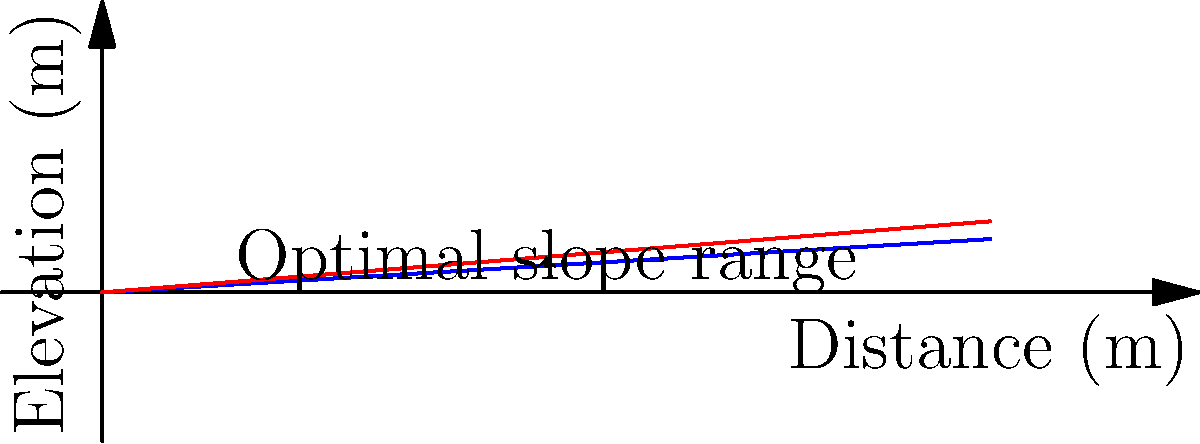As a civil engineer designing a road in Rocklin, you need to determine the optimal slope for proper drainage and safety. Given that the minimum slope for adequate drainage is 6% and the maximum safe slope for vehicles is 8%, what range of slopes (in percent) would you recommend for the road design? Consider factors such as local weather conditions and the hilly terrain of Rocklin. To determine the optimal slope range, we need to consider both the minimum slope for adequate drainage and the maximum safe slope for vehicles. Let's break this down step-by-step:

1. Minimum slope for adequate drainage: 6%
   - This ensures water will flow off the road surface, preventing pooling and potential hydroplaning.

2. Maximum safe slope for vehicles: 8%
   - This limit is set to ensure vehicles can safely navigate the road, especially during wet conditions or when there's reduced traction.

3. Considering Rocklin's local conditions:
   - Rocklin has a Mediterranean climate with hot, dry summers and cool, wet winters.
   - The terrain is hilly, which necessitates careful road design.

4. Optimal slope range:
   - The lower bound is 6% to ensure proper drainage.
   - The upper bound is 8% to maintain safety for vehicles.
   - Any slope within this range (6% - 8%) would be considered optimal.

5. Final considerations:
   - For areas prone to heavy rainfall or where ice formation is a concern, it may be prudent to stay closer to the 6% - 7% range.
   - For flatter areas or where drainage is less critical, slopes closer to 6% might be preferred.
   - In steeper terrain, slopes closer to 8% might be necessary but should be used cautiously.

Therefore, the optimal slope range for road design in Rocklin, considering both drainage and safety factors, would be 6% to 8%.
Answer: 6% - 8% 